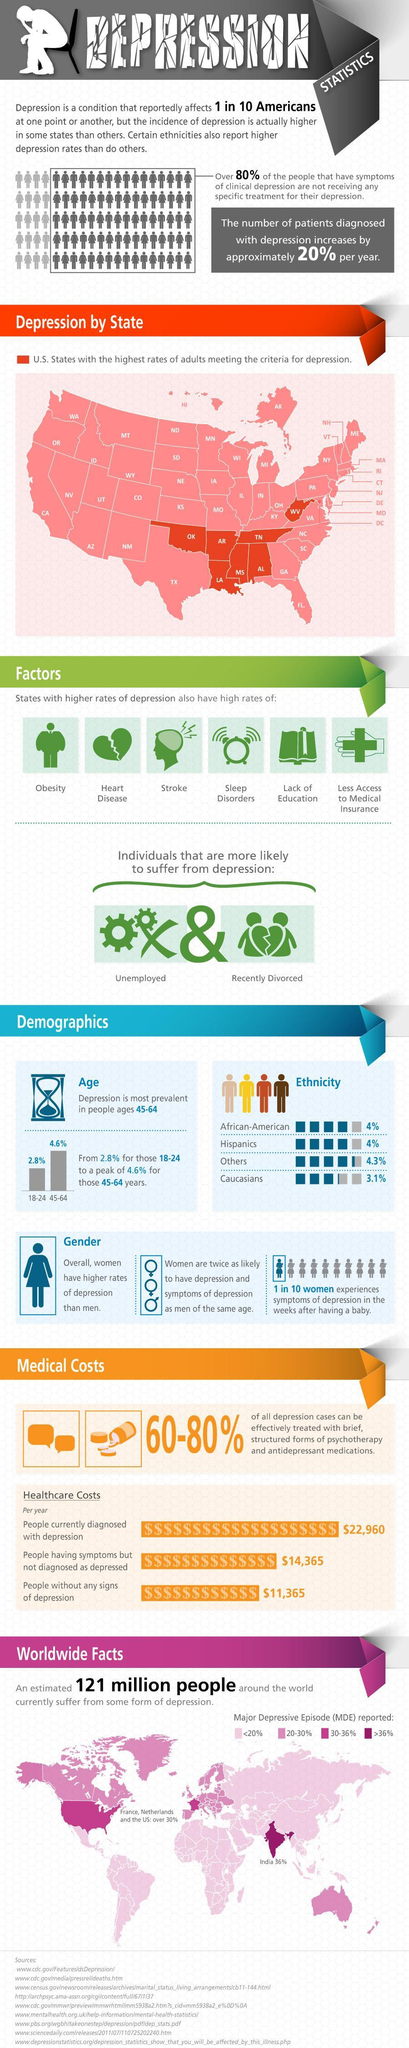In which age group is depression more prevalent?
Answer the question with a short phrase. 45-64 What classes of individuals are most likely to be suffered from Depression? Unemployed & Recently Divorced What percentage of Depression patients increases on a yearly basis in America? 20% 